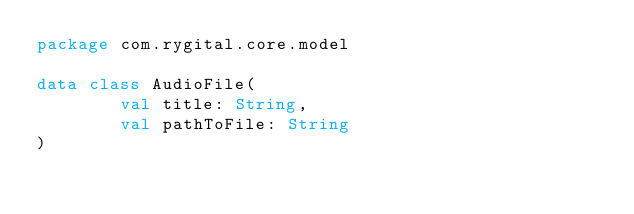Convert code to text. <code><loc_0><loc_0><loc_500><loc_500><_Kotlin_>package com.rygital.core.model

data class AudioFile(
        val title: String,
        val pathToFile: String
)</code> 